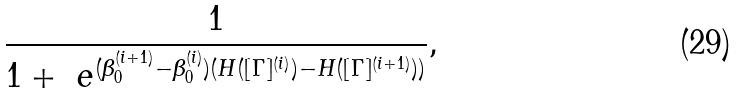Convert formula to latex. <formula><loc_0><loc_0><loc_500><loc_500>\frac { 1 } { 1 + \ e ^ { ( \beta ^ { ( i + 1 ) } _ { 0 } - \beta ^ { ( i ) } _ { 0 } ) ( H ( [ \Gamma ] ^ { ( i ) } ) - H ( [ \Gamma ] ^ { ( i + 1 ) } ) ) } } ,</formula> 